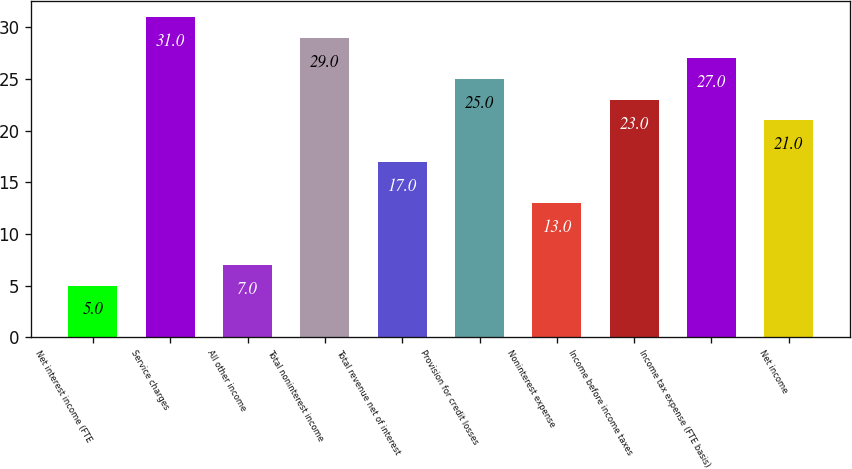Convert chart. <chart><loc_0><loc_0><loc_500><loc_500><bar_chart><fcel>Net interest income (FTE<fcel>Service charges<fcel>All other income<fcel>Total noninterest income<fcel>Total revenue net of interest<fcel>Provision for credit losses<fcel>Noninterest expense<fcel>Income before income taxes<fcel>Income tax expense (FTE basis)<fcel>Net income<nl><fcel>5<fcel>31<fcel>7<fcel>29<fcel>17<fcel>25<fcel>13<fcel>23<fcel>27<fcel>21<nl></chart> 